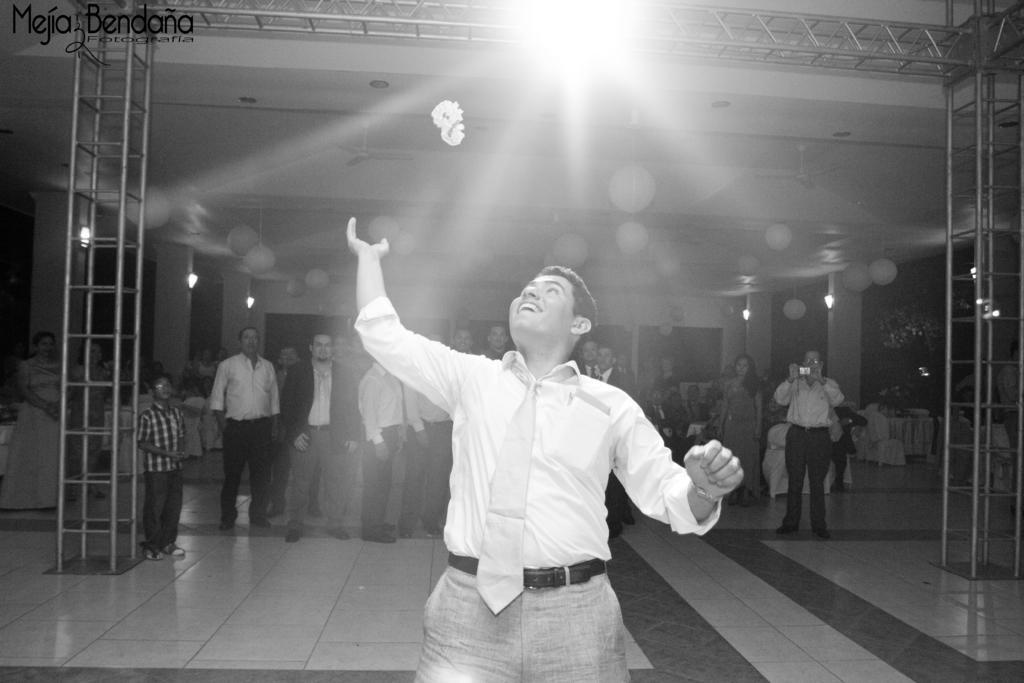In one or two sentences, can you explain what this image depicts? In this picture I can see there is a man standing an din the backdrop I can see there are few others sitting on the chairs, in the backdrop and there is a iron frame here and there are lights attached to the frame. 